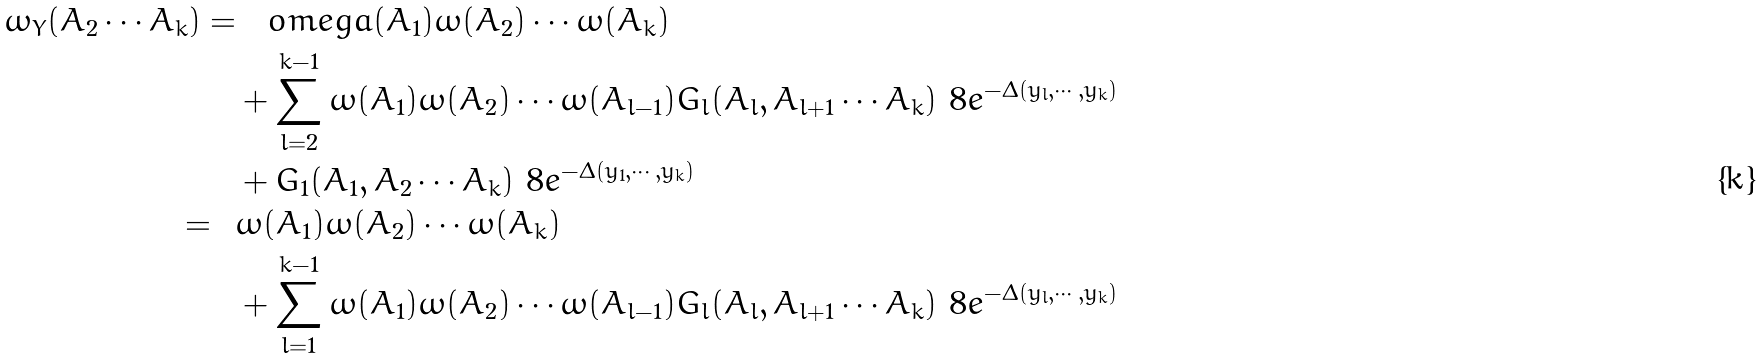Convert formula to latex. <formula><loc_0><loc_0><loc_500><loc_500>\omega _ { Y } ( A _ { 2 } \cdots A _ { k } ) = & \quad o m e g a ( A _ { 1 } ) \omega ( A _ { 2 } ) \cdots \omega ( A _ { k } ) \\ & + \sum _ { l = 2 } ^ { k - 1 } \omega ( A _ { 1 } ) \omega ( A _ { 2 } ) \cdots \omega ( A _ { l - 1 } ) G _ { l } ( A _ { l } , A _ { l + 1 } \cdots A _ { k } ) \ 8 e ^ { - \Delta ( y _ { l } , \cdots , y _ { k } ) } \\ & + G _ { 1 } ( A _ { 1 } , A _ { 2 } \cdots A _ { k } ) \ 8 e ^ { - \Delta ( y _ { 1 } , \cdots , y _ { k } ) } \\ = \ \ & \omega ( A _ { 1 } ) \omega ( A _ { 2 } ) \cdots \omega ( A _ { k } ) \\ & + \sum _ { l = 1 } ^ { k - 1 } \omega ( A _ { 1 } ) \omega ( A _ { 2 } ) \cdots \omega ( A _ { l - 1 } ) G _ { l } ( A _ { l } , A _ { l + 1 } \cdots A _ { k } ) \ 8 e ^ { - \Delta ( y _ { l } , \cdots , y _ { k } ) }</formula> 